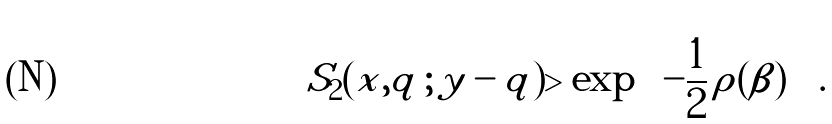Convert formula to latex. <formula><loc_0><loc_0><loc_500><loc_500>S _ { 2 } ( x , q \, ; \, y - q ) > \exp { \left [ - \frac { 1 } { 2 } \, \rho ( \beta ) \right ] } \ .</formula> 